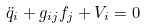<formula> <loc_0><loc_0><loc_500><loc_500>\ddot { q } _ { i } + g _ { i j } f _ { j } + V _ { i } = 0</formula> 